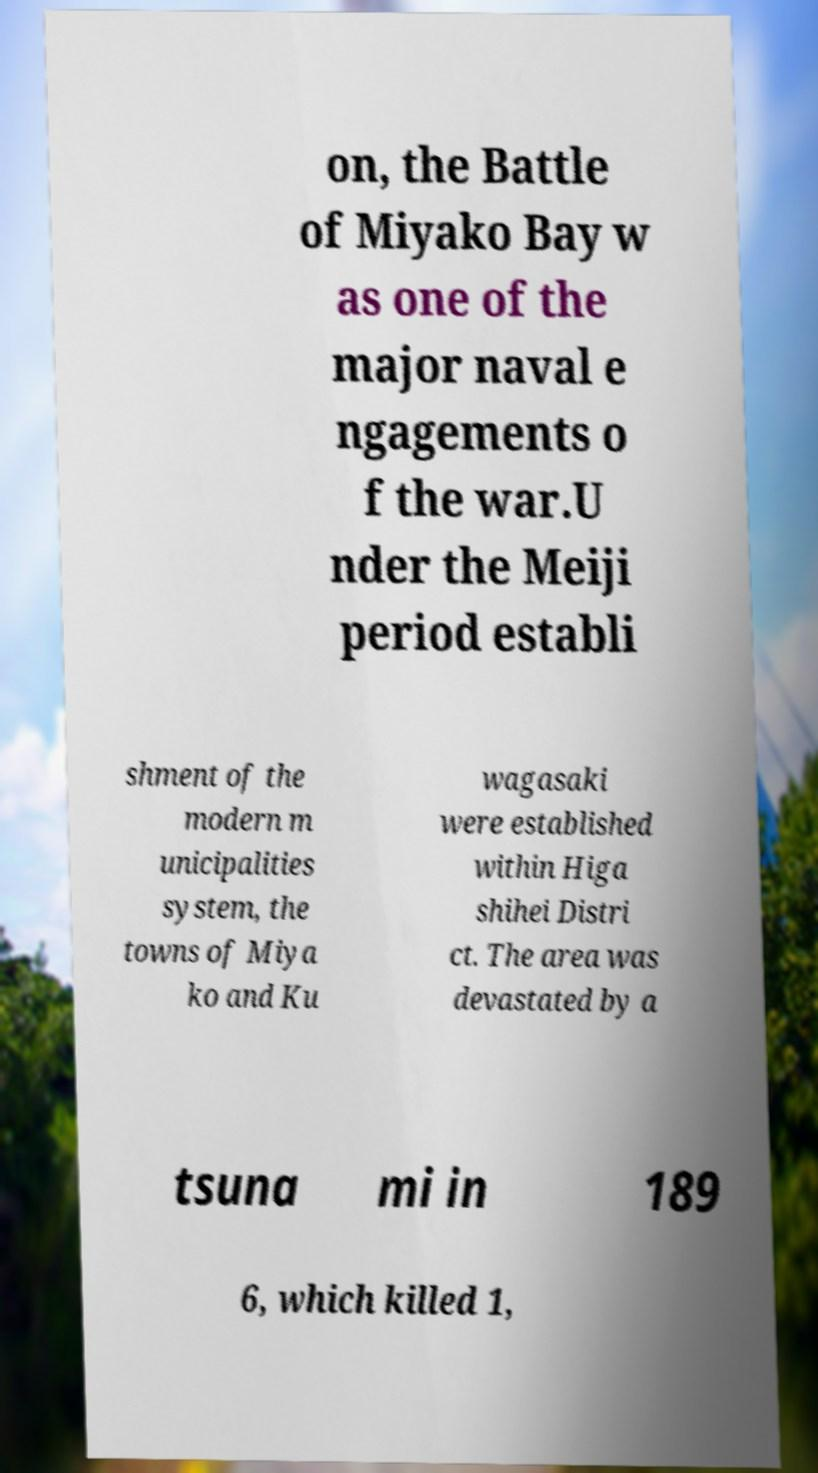Please identify and transcribe the text found in this image. on, the Battle of Miyako Bay w as one of the major naval e ngagements o f the war.U nder the Meiji period establi shment of the modern m unicipalities system, the towns of Miya ko and Ku wagasaki were established within Higa shihei Distri ct. The area was devastated by a tsuna mi in 189 6, which killed 1, 